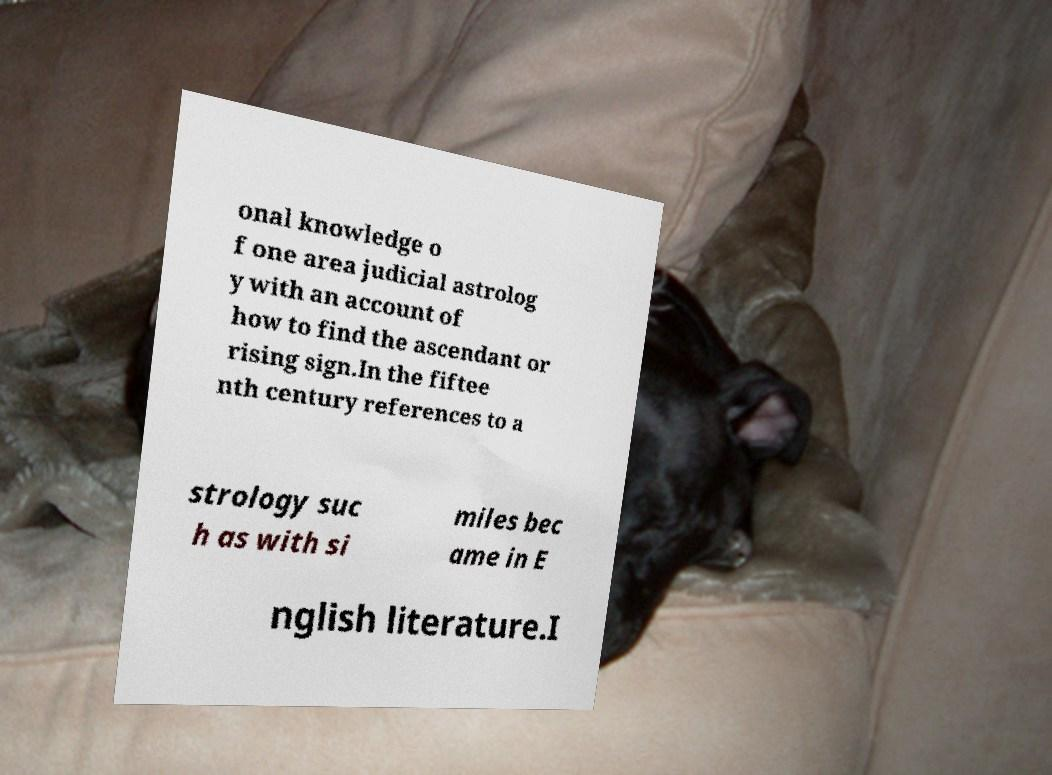I need the written content from this picture converted into text. Can you do that? onal knowledge o f one area judicial astrolog y with an account of how to find the ascendant or rising sign.In the fiftee nth century references to a strology suc h as with si miles bec ame in E nglish literature.I 